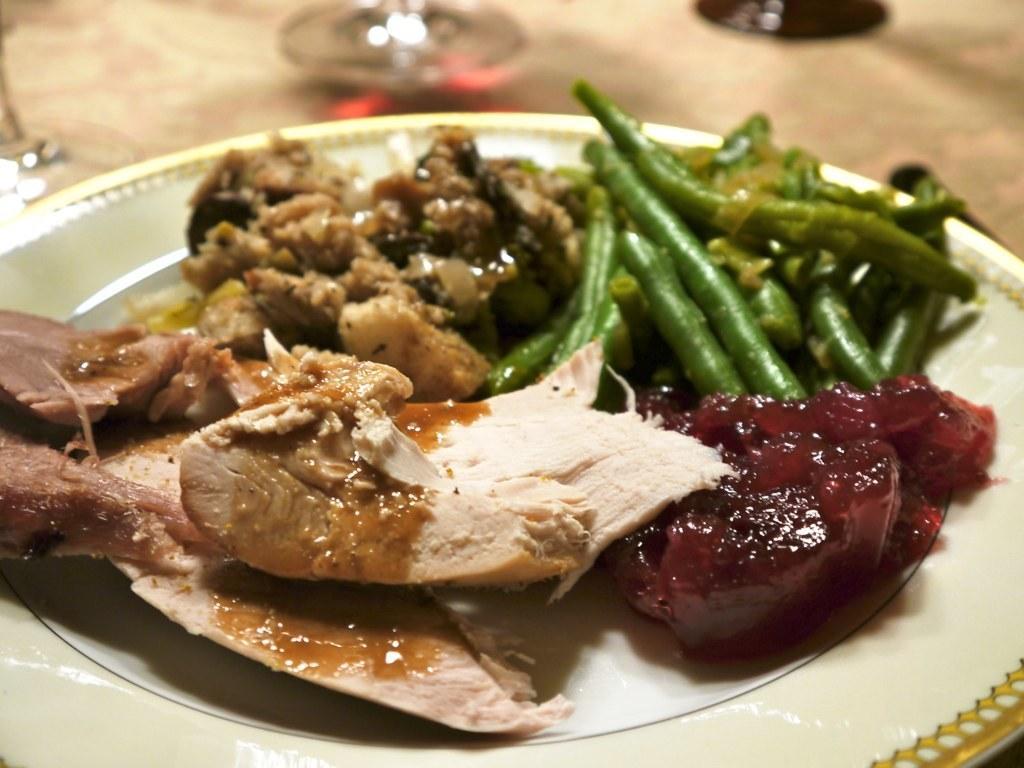Can you describe this image briefly? In the image we can see a plate, white in color. On the plate there are food items, this is a glass and the background is blurred. 